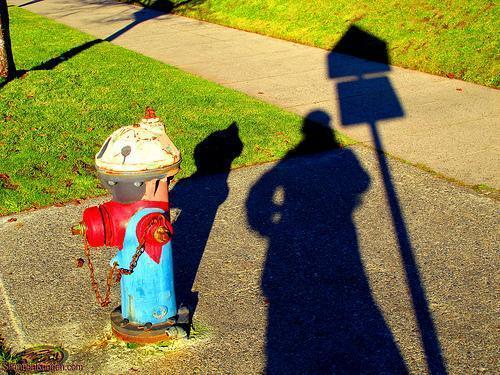How many shadows of signs?
Give a very brief answer. 1. How many hydrants?
Give a very brief answer. 1. 